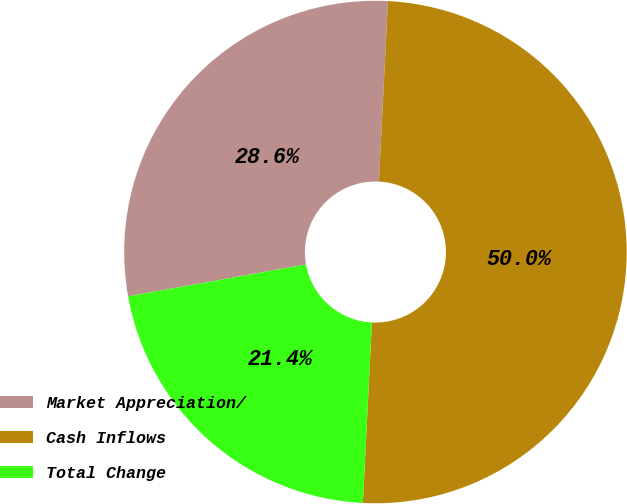Convert chart. <chart><loc_0><loc_0><loc_500><loc_500><pie_chart><fcel>Market Appreciation/<fcel>Cash Inflows<fcel>Total Change<nl><fcel>28.62%<fcel>50.0%<fcel>21.38%<nl></chart> 